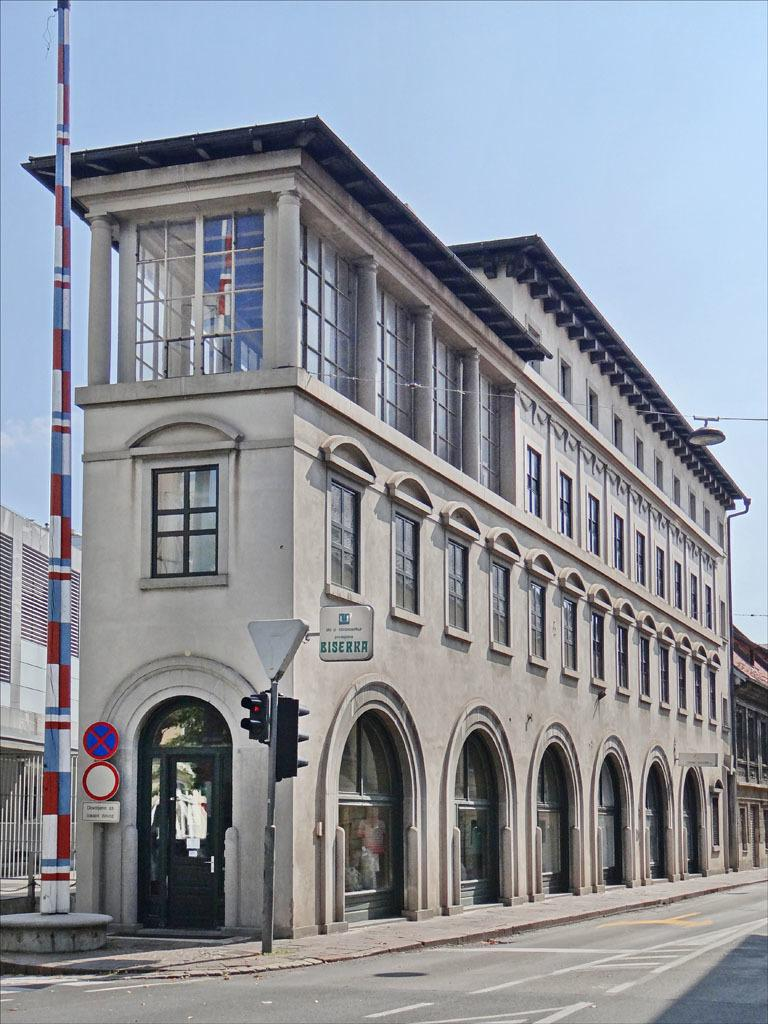What type of structures can be seen in the image? There are buildings in the image. What else can be seen besides the buildings? There is a road, poles, traffic signals, and boards visible in the image. What might be used to control traffic in the image? Traffic signals are present in the image to control traffic. What is visible in the background of the image? The sky is visible in the background of the image. Can you tell me how many horses are flying over the buildings in the image? There are no horses or flying objects present in the image; it only features buildings, a road, poles, traffic signals, boards, and the sky. 